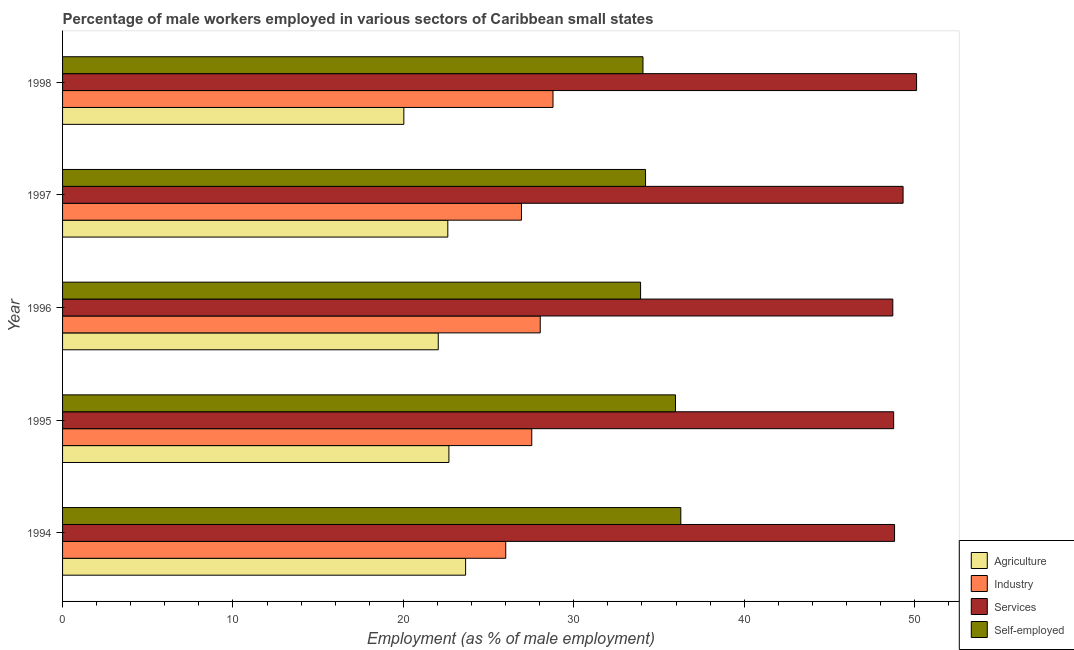How many different coloured bars are there?
Give a very brief answer. 4. Are the number of bars per tick equal to the number of legend labels?
Provide a short and direct response. Yes. Are the number of bars on each tick of the Y-axis equal?
Give a very brief answer. Yes. How many bars are there on the 1st tick from the top?
Provide a succinct answer. 4. What is the label of the 5th group of bars from the top?
Offer a very short reply. 1994. What is the percentage of male workers in agriculture in 1998?
Your answer should be very brief. 20.03. Across all years, what is the maximum percentage of male workers in industry?
Give a very brief answer. 28.78. Across all years, what is the minimum percentage of male workers in services?
Your answer should be very brief. 48.72. What is the total percentage of male workers in services in the graph?
Your answer should be very brief. 245.76. What is the difference between the percentage of male workers in agriculture in 1996 and that in 1997?
Make the answer very short. -0.56. What is the difference between the percentage of male workers in agriculture in 1994 and the percentage of male workers in industry in 1998?
Keep it short and to the point. -5.13. What is the average percentage of male workers in agriculture per year?
Provide a succinct answer. 22.2. In the year 1994, what is the difference between the percentage of male workers in agriculture and percentage of male workers in industry?
Your response must be concise. -2.35. In how many years, is the percentage of male workers in services greater than 26 %?
Provide a succinct answer. 5. What is the ratio of the percentage of male workers in agriculture in 1994 to that in 1995?
Offer a terse response. 1.04. What is the difference between the highest and the second highest percentage of self employed male workers?
Keep it short and to the point. 0.31. What is the difference between the highest and the lowest percentage of self employed male workers?
Ensure brevity in your answer.  2.36. In how many years, is the percentage of male workers in industry greater than the average percentage of male workers in industry taken over all years?
Make the answer very short. 3. Is the sum of the percentage of self employed male workers in 1995 and 1996 greater than the maximum percentage of male workers in services across all years?
Provide a short and direct response. Yes. What does the 1st bar from the top in 1994 represents?
Ensure brevity in your answer.  Self-employed. What does the 1st bar from the bottom in 1998 represents?
Offer a terse response. Agriculture. Are all the bars in the graph horizontal?
Provide a short and direct response. Yes. What is the difference between two consecutive major ticks on the X-axis?
Your response must be concise. 10. Where does the legend appear in the graph?
Ensure brevity in your answer.  Bottom right. How many legend labels are there?
Make the answer very short. 4. What is the title of the graph?
Make the answer very short. Percentage of male workers employed in various sectors of Caribbean small states. What is the label or title of the X-axis?
Keep it short and to the point. Employment (as % of male employment). What is the label or title of the Y-axis?
Offer a very short reply. Year. What is the Employment (as % of male employment) in Agriculture in 1994?
Your answer should be very brief. 23.65. What is the Employment (as % of male employment) of Industry in 1994?
Give a very brief answer. 26.01. What is the Employment (as % of male employment) in Services in 1994?
Your answer should be very brief. 48.82. What is the Employment (as % of male employment) in Self-employed in 1994?
Provide a short and direct response. 36.28. What is the Employment (as % of male employment) in Agriculture in 1995?
Give a very brief answer. 22.67. What is the Employment (as % of male employment) of Industry in 1995?
Provide a succinct answer. 27.53. What is the Employment (as % of male employment) in Services in 1995?
Provide a short and direct response. 48.77. What is the Employment (as % of male employment) of Self-employed in 1995?
Make the answer very short. 35.97. What is the Employment (as % of male employment) in Agriculture in 1996?
Your answer should be compact. 22.05. What is the Employment (as % of male employment) in Industry in 1996?
Give a very brief answer. 28.03. What is the Employment (as % of male employment) of Services in 1996?
Give a very brief answer. 48.72. What is the Employment (as % of male employment) of Self-employed in 1996?
Your answer should be very brief. 33.92. What is the Employment (as % of male employment) of Agriculture in 1997?
Provide a short and direct response. 22.61. What is the Employment (as % of male employment) in Industry in 1997?
Offer a terse response. 26.93. What is the Employment (as % of male employment) in Services in 1997?
Your response must be concise. 49.32. What is the Employment (as % of male employment) of Self-employed in 1997?
Your answer should be compact. 34.21. What is the Employment (as % of male employment) in Agriculture in 1998?
Provide a short and direct response. 20.03. What is the Employment (as % of male employment) of Industry in 1998?
Offer a very short reply. 28.78. What is the Employment (as % of male employment) of Services in 1998?
Your answer should be compact. 50.12. What is the Employment (as % of male employment) in Self-employed in 1998?
Keep it short and to the point. 34.06. Across all years, what is the maximum Employment (as % of male employment) of Agriculture?
Offer a terse response. 23.65. Across all years, what is the maximum Employment (as % of male employment) of Industry?
Give a very brief answer. 28.78. Across all years, what is the maximum Employment (as % of male employment) of Services?
Your response must be concise. 50.12. Across all years, what is the maximum Employment (as % of male employment) of Self-employed?
Provide a succinct answer. 36.28. Across all years, what is the minimum Employment (as % of male employment) of Agriculture?
Keep it short and to the point. 20.03. Across all years, what is the minimum Employment (as % of male employment) of Industry?
Provide a short and direct response. 26.01. Across all years, what is the minimum Employment (as % of male employment) in Services?
Give a very brief answer. 48.72. Across all years, what is the minimum Employment (as % of male employment) in Self-employed?
Offer a terse response. 33.92. What is the total Employment (as % of male employment) of Agriculture in the graph?
Make the answer very short. 111.01. What is the total Employment (as % of male employment) of Industry in the graph?
Your answer should be compact. 137.29. What is the total Employment (as % of male employment) in Services in the graph?
Provide a short and direct response. 245.76. What is the total Employment (as % of male employment) in Self-employed in the graph?
Provide a succinct answer. 174.44. What is the difference between the Employment (as % of male employment) in Agriculture in 1994 and that in 1995?
Your response must be concise. 0.98. What is the difference between the Employment (as % of male employment) of Industry in 1994 and that in 1995?
Keep it short and to the point. -1.53. What is the difference between the Employment (as % of male employment) of Services in 1994 and that in 1995?
Offer a very short reply. 0.05. What is the difference between the Employment (as % of male employment) of Self-employed in 1994 and that in 1995?
Your response must be concise. 0.31. What is the difference between the Employment (as % of male employment) of Agriculture in 1994 and that in 1996?
Your answer should be very brief. 1.61. What is the difference between the Employment (as % of male employment) of Industry in 1994 and that in 1996?
Your response must be concise. -2.02. What is the difference between the Employment (as % of male employment) of Services in 1994 and that in 1996?
Provide a succinct answer. 0.1. What is the difference between the Employment (as % of male employment) in Self-employed in 1994 and that in 1996?
Provide a succinct answer. 2.36. What is the difference between the Employment (as % of male employment) in Agriculture in 1994 and that in 1997?
Give a very brief answer. 1.04. What is the difference between the Employment (as % of male employment) of Industry in 1994 and that in 1997?
Make the answer very short. -0.92. What is the difference between the Employment (as % of male employment) of Services in 1994 and that in 1997?
Your answer should be compact. -0.5. What is the difference between the Employment (as % of male employment) of Self-employed in 1994 and that in 1997?
Your answer should be very brief. 2.07. What is the difference between the Employment (as % of male employment) in Agriculture in 1994 and that in 1998?
Offer a very short reply. 3.62. What is the difference between the Employment (as % of male employment) in Industry in 1994 and that in 1998?
Your response must be concise. -2.77. What is the difference between the Employment (as % of male employment) in Services in 1994 and that in 1998?
Provide a succinct answer. -1.29. What is the difference between the Employment (as % of male employment) in Self-employed in 1994 and that in 1998?
Your answer should be compact. 2.22. What is the difference between the Employment (as % of male employment) of Agriculture in 1995 and that in 1996?
Your response must be concise. 0.63. What is the difference between the Employment (as % of male employment) of Industry in 1995 and that in 1996?
Keep it short and to the point. -0.5. What is the difference between the Employment (as % of male employment) in Services in 1995 and that in 1996?
Your response must be concise. 0.05. What is the difference between the Employment (as % of male employment) of Self-employed in 1995 and that in 1996?
Your response must be concise. 2.05. What is the difference between the Employment (as % of male employment) in Agriculture in 1995 and that in 1997?
Give a very brief answer. 0.06. What is the difference between the Employment (as % of male employment) of Industry in 1995 and that in 1997?
Your answer should be compact. 0.6. What is the difference between the Employment (as % of male employment) in Services in 1995 and that in 1997?
Provide a short and direct response. -0.55. What is the difference between the Employment (as % of male employment) in Self-employed in 1995 and that in 1997?
Your answer should be compact. 1.76. What is the difference between the Employment (as % of male employment) in Agriculture in 1995 and that in 1998?
Your response must be concise. 2.64. What is the difference between the Employment (as % of male employment) in Industry in 1995 and that in 1998?
Provide a short and direct response. -1.25. What is the difference between the Employment (as % of male employment) in Services in 1995 and that in 1998?
Your answer should be compact. -1.34. What is the difference between the Employment (as % of male employment) in Self-employed in 1995 and that in 1998?
Your answer should be very brief. 1.91. What is the difference between the Employment (as % of male employment) of Agriculture in 1996 and that in 1997?
Provide a short and direct response. -0.56. What is the difference between the Employment (as % of male employment) in Industry in 1996 and that in 1997?
Your answer should be very brief. 1.1. What is the difference between the Employment (as % of male employment) in Services in 1996 and that in 1997?
Provide a succinct answer. -0.6. What is the difference between the Employment (as % of male employment) in Self-employed in 1996 and that in 1997?
Give a very brief answer. -0.29. What is the difference between the Employment (as % of male employment) in Agriculture in 1996 and that in 1998?
Your answer should be compact. 2.02. What is the difference between the Employment (as % of male employment) in Industry in 1996 and that in 1998?
Ensure brevity in your answer.  -0.75. What is the difference between the Employment (as % of male employment) of Services in 1996 and that in 1998?
Provide a succinct answer. -1.39. What is the difference between the Employment (as % of male employment) in Self-employed in 1996 and that in 1998?
Offer a terse response. -0.14. What is the difference between the Employment (as % of male employment) in Agriculture in 1997 and that in 1998?
Make the answer very short. 2.58. What is the difference between the Employment (as % of male employment) in Industry in 1997 and that in 1998?
Your response must be concise. -1.85. What is the difference between the Employment (as % of male employment) in Services in 1997 and that in 1998?
Your response must be concise. -0.79. What is the difference between the Employment (as % of male employment) in Self-employed in 1997 and that in 1998?
Your answer should be very brief. 0.15. What is the difference between the Employment (as % of male employment) of Agriculture in 1994 and the Employment (as % of male employment) of Industry in 1995?
Provide a short and direct response. -3.88. What is the difference between the Employment (as % of male employment) in Agriculture in 1994 and the Employment (as % of male employment) in Services in 1995?
Your answer should be very brief. -25.12. What is the difference between the Employment (as % of male employment) in Agriculture in 1994 and the Employment (as % of male employment) in Self-employed in 1995?
Your answer should be compact. -12.32. What is the difference between the Employment (as % of male employment) in Industry in 1994 and the Employment (as % of male employment) in Services in 1995?
Provide a succinct answer. -22.76. What is the difference between the Employment (as % of male employment) of Industry in 1994 and the Employment (as % of male employment) of Self-employed in 1995?
Your answer should be very brief. -9.96. What is the difference between the Employment (as % of male employment) in Services in 1994 and the Employment (as % of male employment) in Self-employed in 1995?
Offer a terse response. 12.86. What is the difference between the Employment (as % of male employment) in Agriculture in 1994 and the Employment (as % of male employment) in Industry in 1996?
Ensure brevity in your answer.  -4.38. What is the difference between the Employment (as % of male employment) in Agriculture in 1994 and the Employment (as % of male employment) in Services in 1996?
Give a very brief answer. -25.07. What is the difference between the Employment (as % of male employment) in Agriculture in 1994 and the Employment (as % of male employment) in Self-employed in 1996?
Your answer should be very brief. -10.27. What is the difference between the Employment (as % of male employment) of Industry in 1994 and the Employment (as % of male employment) of Services in 1996?
Give a very brief answer. -22.71. What is the difference between the Employment (as % of male employment) in Industry in 1994 and the Employment (as % of male employment) in Self-employed in 1996?
Ensure brevity in your answer.  -7.91. What is the difference between the Employment (as % of male employment) in Services in 1994 and the Employment (as % of male employment) in Self-employed in 1996?
Give a very brief answer. 14.9. What is the difference between the Employment (as % of male employment) of Agriculture in 1994 and the Employment (as % of male employment) of Industry in 1997?
Offer a terse response. -3.28. What is the difference between the Employment (as % of male employment) of Agriculture in 1994 and the Employment (as % of male employment) of Services in 1997?
Your answer should be very brief. -25.67. What is the difference between the Employment (as % of male employment) of Agriculture in 1994 and the Employment (as % of male employment) of Self-employed in 1997?
Your response must be concise. -10.56. What is the difference between the Employment (as % of male employment) in Industry in 1994 and the Employment (as % of male employment) in Services in 1997?
Give a very brief answer. -23.32. What is the difference between the Employment (as % of male employment) in Industry in 1994 and the Employment (as % of male employment) in Self-employed in 1997?
Your answer should be compact. -8.2. What is the difference between the Employment (as % of male employment) of Services in 1994 and the Employment (as % of male employment) of Self-employed in 1997?
Ensure brevity in your answer.  14.61. What is the difference between the Employment (as % of male employment) in Agriculture in 1994 and the Employment (as % of male employment) in Industry in 1998?
Make the answer very short. -5.13. What is the difference between the Employment (as % of male employment) of Agriculture in 1994 and the Employment (as % of male employment) of Services in 1998?
Offer a terse response. -26.46. What is the difference between the Employment (as % of male employment) in Agriculture in 1994 and the Employment (as % of male employment) in Self-employed in 1998?
Ensure brevity in your answer.  -10.41. What is the difference between the Employment (as % of male employment) in Industry in 1994 and the Employment (as % of male employment) in Services in 1998?
Make the answer very short. -24.11. What is the difference between the Employment (as % of male employment) of Industry in 1994 and the Employment (as % of male employment) of Self-employed in 1998?
Your answer should be compact. -8.05. What is the difference between the Employment (as % of male employment) in Services in 1994 and the Employment (as % of male employment) in Self-employed in 1998?
Offer a terse response. 14.76. What is the difference between the Employment (as % of male employment) of Agriculture in 1995 and the Employment (as % of male employment) of Industry in 1996?
Your answer should be compact. -5.36. What is the difference between the Employment (as % of male employment) of Agriculture in 1995 and the Employment (as % of male employment) of Services in 1996?
Provide a short and direct response. -26.05. What is the difference between the Employment (as % of male employment) of Agriculture in 1995 and the Employment (as % of male employment) of Self-employed in 1996?
Keep it short and to the point. -11.25. What is the difference between the Employment (as % of male employment) in Industry in 1995 and the Employment (as % of male employment) in Services in 1996?
Your answer should be very brief. -21.19. What is the difference between the Employment (as % of male employment) in Industry in 1995 and the Employment (as % of male employment) in Self-employed in 1996?
Provide a succinct answer. -6.39. What is the difference between the Employment (as % of male employment) in Services in 1995 and the Employment (as % of male employment) in Self-employed in 1996?
Offer a very short reply. 14.85. What is the difference between the Employment (as % of male employment) in Agriculture in 1995 and the Employment (as % of male employment) in Industry in 1997?
Make the answer very short. -4.26. What is the difference between the Employment (as % of male employment) in Agriculture in 1995 and the Employment (as % of male employment) in Services in 1997?
Your answer should be very brief. -26.65. What is the difference between the Employment (as % of male employment) of Agriculture in 1995 and the Employment (as % of male employment) of Self-employed in 1997?
Provide a succinct answer. -11.54. What is the difference between the Employment (as % of male employment) of Industry in 1995 and the Employment (as % of male employment) of Services in 1997?
Your answer should be compact. -21.79. What is the difference between the Employment (as % of male employment) in Industry in 1995 and the Employment (as % of male employment) in Self-employed in 1997?
Offer a very short reply. -6.68. What is the difference between the Employment (as % of male employment) in Services in 1995 and the Employment (as % of male employment) in Self-employed in 1997?
Provide a short and direct response. 14.56. What is the difference between the Employment (as % of male employment) in Agriculture in 1995 and the Employment (as % of male employment) in Industry in 1998?
Your response must be concise. -6.11. What is the difference between the Employment (as % of male employment) of Agriculture in 1995 and the Employment (as % of male employment) of Services in 1998?
Provide a short and direct response. -27.44. What is the difference between the Employment (as % of male employment) of Agriculture in 1995 and the Employment (as % of male employment) of Self-employed in 1998?
Your answer should be very brief. -11.39. What is the difference between the Employment (as % of male employment) in Industry in 1995 and the Employment (as % of male employment) in Services in 1998?
Give a very brief answer. -22.58. What is the difference between the Employment (as % of male employment) of Industry in 1995 and the Employment (as % of male employment) of Self-employed in 1998?
Offer a terse response. -6.53. What is the difference between the Employment (as % of male employment) of Services in 1995 and the Employment (as % of male employment) of Self-employed in 1998?
Offer a terse response. 14.71. What is the difference between the Employment (as % of male employment) in Agriculture in 1996 and the Employment (as % of male employment) in Industry in 1997?
Keep it short and to the point. -4.89. What is the difference between the Employment (as % of male employment) of Agriculture in 1996 and the Employment (as % of male employment) of Services in 1997?
Your answer should be compact. -27.28. What is the difference between the Employment (as % of male employment) of Agriculture in 1996 and the Employment (as % of male employment) of Self-employed in 1997?
Make the answer very short. -12.17. What is the difference between the Employment (as % of male employment) in Industry in 1996 and the Employment (as % of male employment) in Services in 1997?
Your answer should be compact. -21.29. What is the difference between the Employment (as % of male employment) in Industry in 1996 and the Employment (as % of male employment) in Self-employed in 1997?
Your response must be concise. -6.18. What is the difference between the Employment (as % of male employment) in Services in 1996 and the Employment (as % of male employment) in Self-employed in 1997?
Your response must be concise. 14.51. What is the difference between the Employment (as % of male employment) in Agriculture in 1996 and the Employment (as % of male employment) in Industry in 1998?
Provide a short and direct response. -6.73. What is the difference between the Employment (as % of male employment) of Agriculture in 1996 and the Employment (as % of male employment) of Services in 1998?
Your response must be concise. -28.07. What is the difference between the Employment (as % of male employment) in Agriculture in 1996 and the Employment (as % of male employment) in Self-employed in 1998?
Your response must be concise. -12.01. What is the difference between the Employment (as % of male employment) of Industry in 1996 and the Employment (as % of male employment) of Services in 1998?
Provide a succinct answer. -22.09. What is the difference between the Employment (as % of male employment) in Industry in 1996 and the Employment (as % of male employment) in Self-employed in 1998?
Make the answer very short. -6.03. What is the difference between the Employment (as % of male employment) in Services in 1996 and the Employment (as % of male employment) in Self-employed in 1998?
Provide a short and direct response. 14.66. What is the difference between the Employment (as % of male employment) in Agriculture in 1997 and the Employment (as % of male employment) in Industry in 1998?
Ensure brevity in your answer.  -6.17. What is the difference between the Employment (as % of male employment) in Agriculture in 1997 and the Employment (as % of male employment) in Services in 1998?
Your response must be concise. -27.51. What is the difference between the Employment (as % of male employment) in Agriculture in 1997 and the Employment (as % of male employment) in Self-employed in 1998?
Ensure brevity in your answer.  -11.45. What is the difference between the Employment (as % of male employment) in Industry in 1997 and the Employment (as % of male employment) in Services in 1998?
Offer a very short reply. -23.18. What is the difference between the Employment (as % of male employment) in Industry in 1997 and the Employment (as % of male employment) in Self-employed in 1998?
Give a very brief answer. -7.13. What is the difference between the Employment (as % of male employment) in Services in 1997 and the Employment (as % of male employment) in Self-employed in 1998?
Give a very brief answer. 15.26. What is the average Employment (as % of male employment) of Agriculture per year?
Keep it short and to the point. 22.2. What is the average Employment (as % of male employment) of Industry per year?
Ensure brevity in your answer.  27.46. What is the average Employment (as % of male employment) in Services per year?
Give a very brief answer. 49.15. What is the average Employment (as % of male employment) of Self-employed per year?
Your answer should be very brief. 34.89. In the year 1994, what is the difference between the Employment (as % of male employment) of Agriculture and Employment (as % of male employment) of Industry?
Ensure brevity in your answer.  -2.36. In the year 1994, what is the difference between the Employment (as % of male employment) of Agriculture and Employment (as % of male employment) of Services?
Offer a terse response. -25.17. In the year 1994, what is the difference between the Employment (as % of male employment) in Agriculture and Employment (as % of male employment) in Self-employed?
Provide a short and direct response. -12.63. In the year 1994, what is the difference between the Employment (as % of male employment) of Industry and Employment (as % of male employment) of Services?
Your answer should be compact. -22.82. In the year 1994, what is the difference between the Employment (as % of male employment) in Industry and Employment (as % of male employment) in Self-employed?
Offer a very short reply. -10.27. In the year 1994, what is the difference between the Employment (as % of male employment) of Services and Employment (as % of male employment) of Self-employed?
Provide a short and direct response. 12.54. In the year 1995, what is the difference between the Employment (as % of male employment) in Agriculture and Employment (as % of male employment) in Industry?
Ensure brevity in your answer.  -4.86. In the year 1995, what is the difference between the Employment (as % of male employment) in Agriculture and Employment (as % of male employment) in Services?
Give a very brief answer. -26.1. In the year 1995, what is the difference between the Employment (as % of male employment) in Agriculture and Employment (as % of male employment) in Self-employed?
Offer a terse response. -13.3. In the year 1995, what is the difference between the Employment (as % of male employment) of Industry and Employment (as % of male employment) of Services?
Offer a very short reply. -21.24. In the year 1995, what is the difference between the Employment (as % of male employment) of Industry and Employment (as % of male employment) of Self-employed?
Provide a short and direct response. -8.43. In the year 1995, what is the difference between the Employment (as % of male employment) of Services and Employment (as % of male employment) of Self-employed?
Provide a short and direct response. 12.8. In the year 1996, what is the difference between the Employment (as % of male employment) in Agriculture and Employment (as % of male employment) in Industry?
Your answer should be very brief. -5.99. In the year 1996, what is the difference between the Employment (as % of male employment) of Agriculture and Employment (as % of male employment) of Services?
Ensure brevity in your answer.  -26.68. In the year 1996, what is the difference between the Employment (as % of male employment) of Agriculture and Employment (as % of male employment) of Self-employed?
Give a very brief answer. -11.87. In the year 1996, what is the difference between the Employment (as % of male employment) of Industry and Employment (as % of male employment) of Services?
Provide a short and direct response. -20.69. In the year 1996, what is the difference between the Employment (as % of male employment) in Industry and Employment (as % of male employment) in Self-employed?
Offer a very short reply. -5.89. In the year 1996, what is the difference between the Employment (as % of male employment) in Services and Employment (as % of male employment) in Self-employed?
Your answer should be compact. 14.8. In the year 1997, what is the difference between the Employment (as % of male employment) in Agriculture and Employment (as % of male employment) in Industry?
Make the answer very short. -4.32. In the year 1997, what is the difference between the Employment (as % of male employment) in Agriculture and Employment (as % of male employment) in Services?
Provide a short and direct response. -26.72. In the year 1997, what is the difference between the Employment (as % of male employment) in Agriculture and Employment (as % of male employment) in Self-employed?
Offer a very short reply. -11.6. In the year 1997, what is the difference between the Employment (as % of male employment) in Industry and Employment (as % of male employment) in Services?
Provide a succinct answer. -22.39. In the year 1997, what is the difference between the Employment (as % of male employment) in Industry and Employment (as % of male employment) in Self-employed?
Make the answer very short. -7.28. In the year 1997, what is the difference between the Employment (as % of male employment) of Services and Employment (as % of male employment) of Self-employed?
Offer a very short reply. 15.11. In the year 1998, what is the difference between the Employment (as % of male employment) of Agriculture and Employment (as % of male employment) of Industry?
Give a very brief answer. -8.75. In the year 1998, what is the difference between the Employment (as % of male employment) in Agriculture and Employment (as % of male employment) in Services?
Ensure brevity in your answer.  -30.09. In the year 1998, what is the difference between the Employment (as % of male employment) of Agriculture and Employment (as % of male employment) of Self-employed?
Provide a short and direct response. -14.03. In the year 1998, what is the difference between the Employment (as % of male employment) in Industry and Employment (as % of male employment) in Services?
Offer a very short reply. -21.34. In the year 1998, what is the difference between the Employment (as % of male employment) in Industry and Employment (as % of male employment) in Self-employed?
Offer a terse response. -5.28. In the year 1998, what is the difference between the Employment (as % of male employment) in Services and Employment (as % of male employment) in Self-employed?
Provide a short and direct response. 16.06. What is the ratio of the Employment (as % of male employment) of Agriculture in 1994 to that in 1995?
Give a very brief answer. 1.04. What is the ratio of the Employment (as % of male employment) in Industry in 1994 to that in 1995?
Your answer should be compact. 0.94. What is the ratio of the Employment (as % of male employment) of Self-employed in 1994 to that in 1995?
Your response must be concise. 1.01. What is the ratio of the Employment (as % of male employment) of Agriculture in 1994 to that in 1996?
Your answer should be compact. 1.07. What is the ratio of the Employment (as % of male employment) of Industry in 1994 to that in 1996?
Provide a short and direct response. 0.93. What is the ratio of the Employment (as % of male employment) of Services in 1994 to that in 1996?
Keep it short and to the point. 1. What is the ratio of the Employment (as % of male employment) of Self-employed in 1994 to that in 1996?
Your response must be concise. 1.07. What is the ratio of the Employment (as % of male employment) in Agriculture in 1994 to that in 1997?
Keep it short and to the point. 1.05. What is the ratio of the Employment (as % of male employment) in Industry in 1994 to that in 1997?
Offer a terse response. 0.97. What is the ratio of the Employment (as % of male employment) of Services in 1994 to that in 1997?
Ensure brevity in your answer.  0.99. What is the ratio of the Employment (as % of male employment) in Self-employed in 1994 to that in 1997?
Your response must be concise. 1.06. What is the ratio of the Employment (as % of male employment) of Agriculture in 1994 to that in 1998?
Give a very brief answer. 1.18. What is the ratio of the Employment (as % of male employment) in Industry in 1994 to that in 1998?
Offer a terse response. 0.9. What is the ratio of the Employment (as % of male employment) in Services in 1994 to that in 1998?
Give a very brief answer. 0.97. What is the ratio of the Employment (as % of male employment) in Self-employed in 1994 to that in 1998?
Offer a very short reply. 1.07. What is the ratio of the Employment (as % of male employment) of Agriculture in 1995 to that in 1996?
Your answer should be compact. 1.03. What is the ratio of the Employment (as % of male employment) of Industry in 1995 to that in 1996?
Your response must be concise. 0.98. What is the ratio of the Employment (as % of male employment) of Self-employed in 1995 to that in 1996?
Provide a short and direct response. 1.06. What is the ratio of the Employment (as % of male employment) of Agriculture in 1995 to that in 1997?
Your answer should be compact. 1. What is the ratio of the Employment (as % of male employment) in Industry in 1995 to that in 1997?
Give a very brief answer. 1.02. What is the ratio of the Employment (as % of male employment) of Services in 1995 to that in 1997?
Keep it short and to the point. 0.99. What is the ratio of the Employment (as % of male employment) of Self-employed in 1995 to that in 1997?
Make the answer very short. 1.05. What is the ratio of the Employment (as % of male employment) of Agriculture in 1995 to that in 1998?
Ensure brevity in your answer.  1.13. What is the ratio of the Employment (as % of male employment) in Industry in 1995 to that in 1998?
Your answer should be very brief. 0.96. What is the ratio of the Employment (as % of male employment) of Services in 1995 to that in 1998?
Your answer should be compact. 0.97. What is the ratio of the Employment (as % of male employment) of Self-employed in 1995 to that in 1998?
Provide a succinct answer. 1.06. What is the ratio of the Employment (as % of male employment) in Agriculture in 1996 to that in 1997?
Your answer should be compact. 0.98. What is the ratio of the Employment (as % of male employment) in Industry in 1996 to that in 1997?
Your answer should be compact. 1.04. What is the ratio of the Employment (as % of male employment) in Self-employed in 1996 to that in 1997?
Your answer should be very brief. 0.99. What is the ratio of the Employment (as % of male employment) of Agriculture in 1996 to that in 1998?
Make the answer very short. 1.1. What is the ratio of the Employment (as % of male employment) in Industry in 1996 to that in 1998?
Give a very brief answer. 0.97. What is the ratio of the Employment (as % of male employment) in Services in 1996 to that in 1998?
Keep it short and to the point. 0.97. What is the ratio of the Employment (as % of male employment) in Self-employed in 1996 to that in 1998?
Provide a short and direct response. 1. What is the ratio of the Employment (as % of male employment) of Agriculture in 1997 to that in 1998?
Provide a short and direct response. 1.13. What is the ratio of the Employment (as % of male employment) in Industry in 1997 to that in 1998?
Provide a short and direct response. 0.94. What is the ratio of the Employment (as % of male employment) of Services in 1997 to that in 1998?
Your answer should be very brief. 0.98. What is the difference between the highest and the second highest Employment (as % of male employment) of Agriculture?
Ensure brevity in your answer.  0.98. What is the difference between the highest and the second highest Employment (as % of male employment) of Industry?
Your response must be concise. 0.75. What is the difference between the highest and the second highest Employment (as % of male employment) in Services?
Offer a very short reply. 0.79. What is the difference between the highest and the second highest Employment (as % of male employment) in Self-employed?
Your response must be concise. 0.31. What is the difference between the highest and the lowest Employment (as % of male employment) of Agriculture?
Your answer should be compact. 3.62. What is the difference between the highest and the lowest Employment (as % of male employment) of Industry?
Your answer should be very brief. 2.77. What is the difference between the highest and the lowest Employment (as % of male employment) of Services?
Give a very brief answer. 1.39. What is the difference between the highest and the lowest Employment (as % of male employment) in Self-employed?
Offer a terse response. 2.36. 